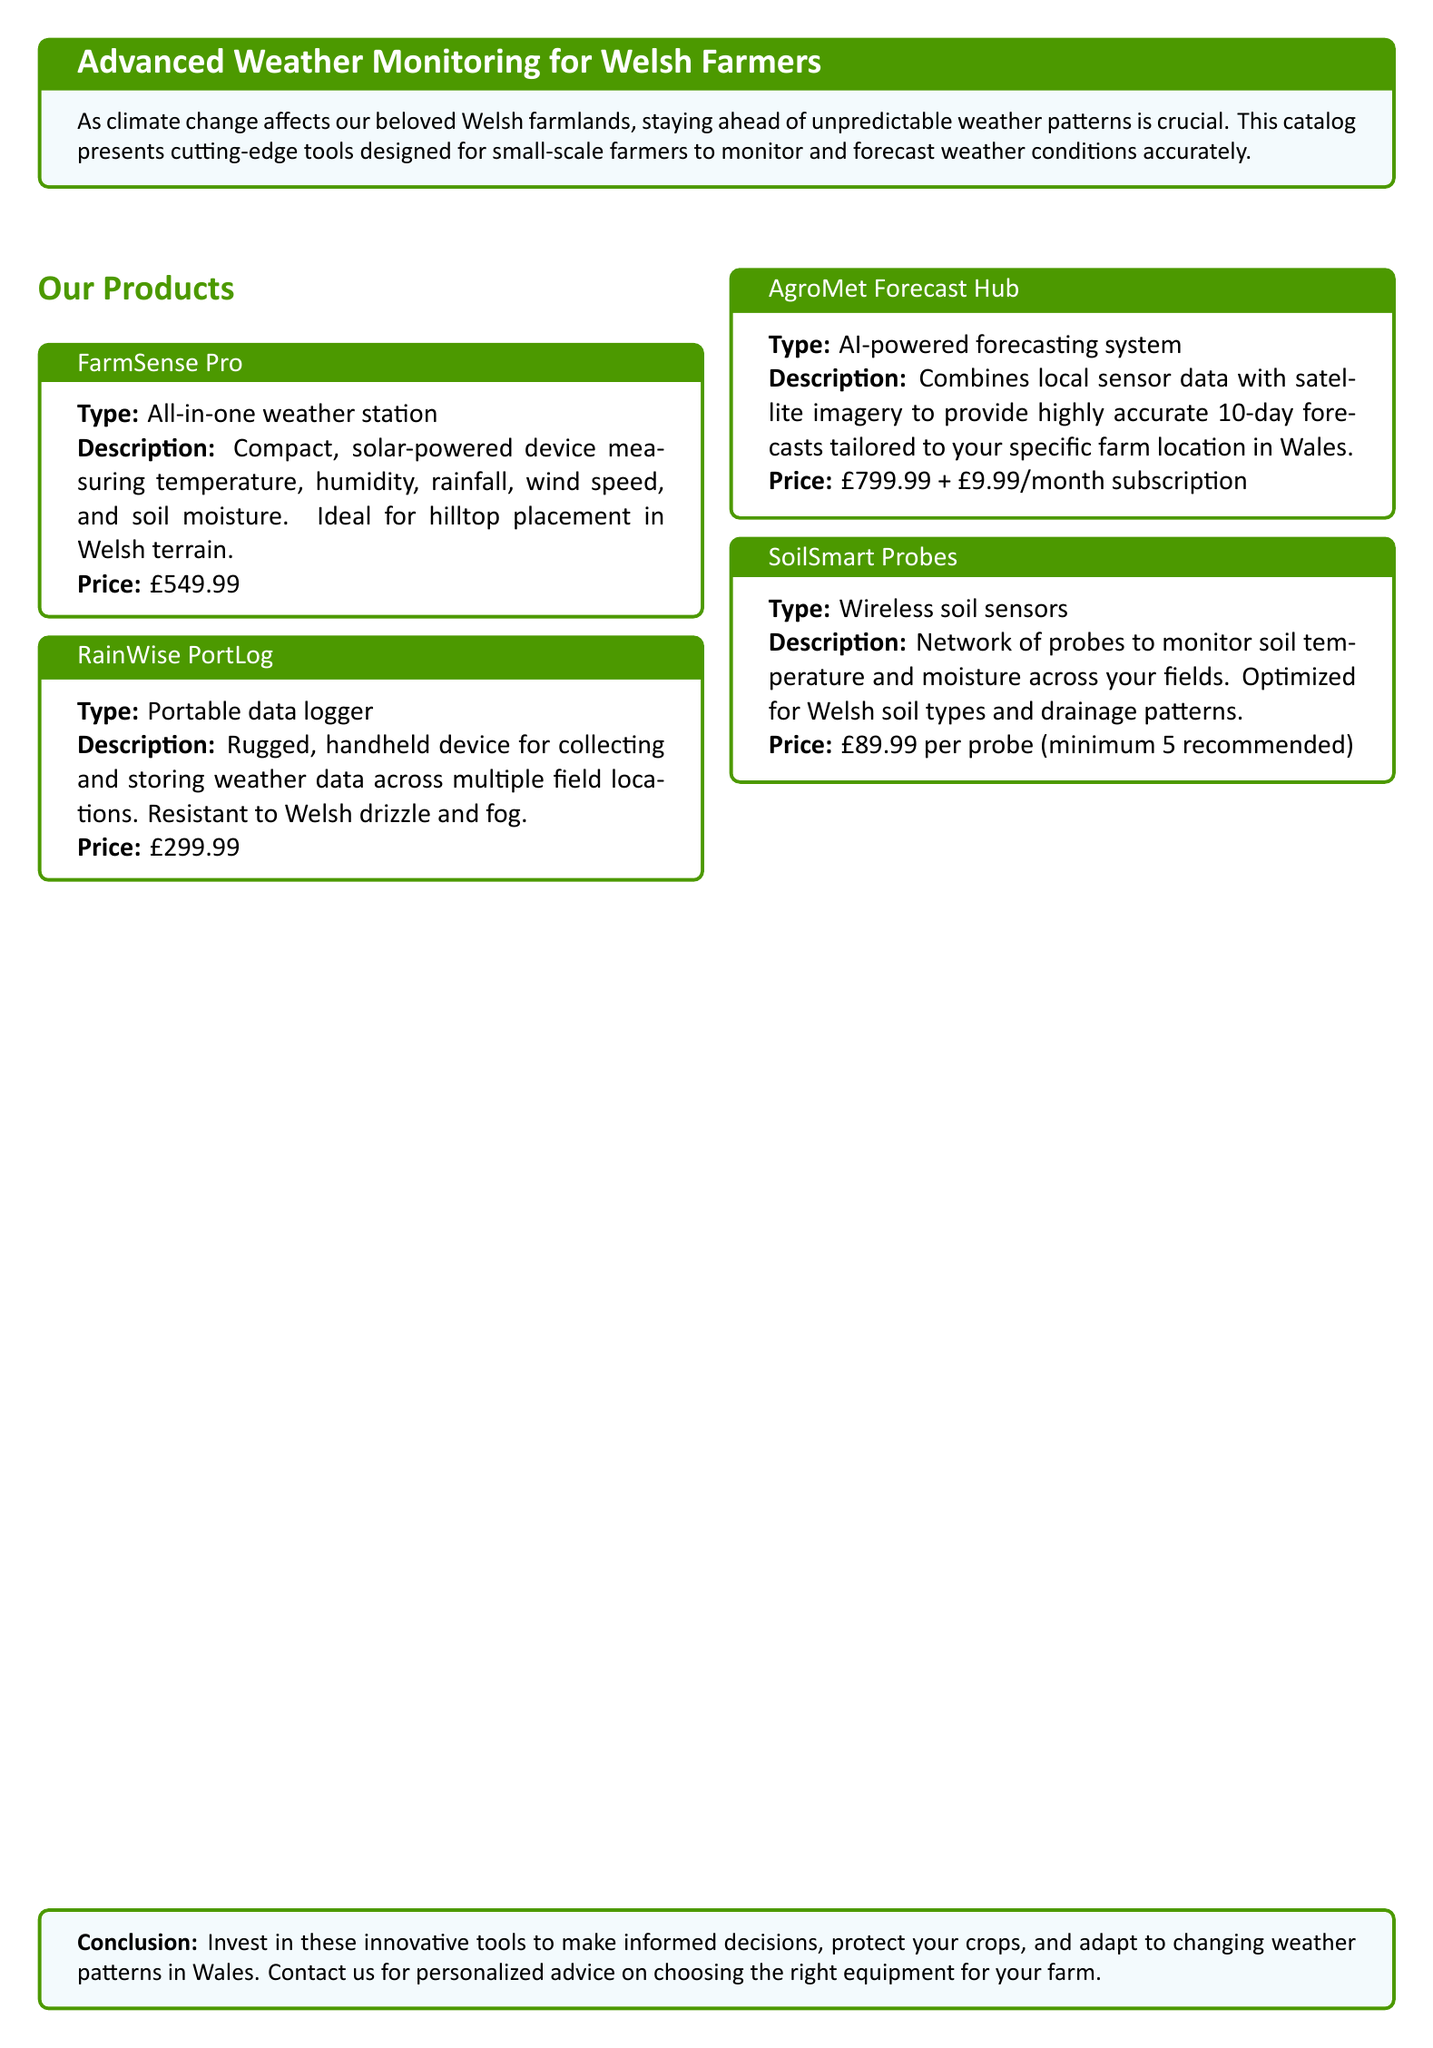What is the price of FarmSense Pro? The price is listed directly in the document for the FarmSense Pro product.
Answer: £549.99 What types of weather data does the FarmSense Pro measure? The product description specifically states the types of measurements it makes.
Answer: Temperature, humidity, rainfall, wind speed, and soil moisture How is the RainWise PortLog described? The document provides a description of the RainWise PortLog, highlighting its features.
Answer: Rugged, handheld device for collecting and storing weather data What is the monthly subscription cost for AgroMet Forecast Hub? The price information states an additional cost for using the AgroMet service monthly.
Answer: £9.99/month How many probes are recommended for the SoilSmart Probes? The SoilSmart Probes section suggests a minimum number for efficient use.
Answer: Minimum 5 recommended What unique feature does AgroMet Forecast Hub utilize for forecasting? The description indicates the technology that enhances the forecasting system.
Answer: AI-powered forecasting system What color is used for section titles in the document? The document specifies the color for the section titles.
Answer: Grass green What is the conclusion in this catalog? The last section summarizes the overall aim of the products offered.
Answer: Invest in these innovative tools to make informed decisions 